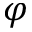Convert formula to latex. <formula><loc_0><loc_0><loc_500><loc_500>\varphi</formula> 